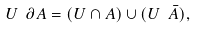<formula> <loc_0><loc_0><loc_500><loc_500>U \ \partial A = ( U \cap A ) \cup ( U \ \bar { A } ) ,</formula> 